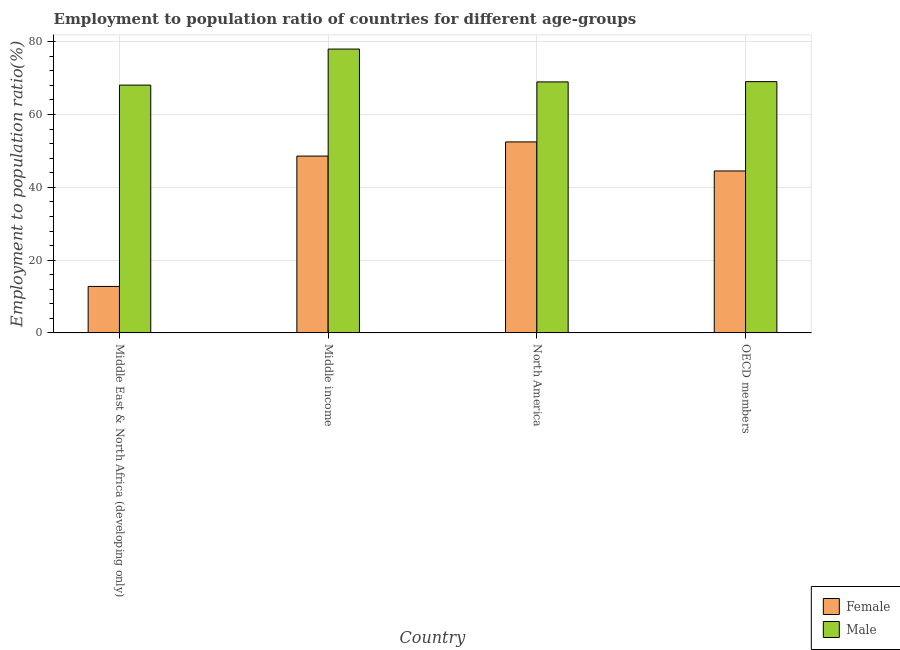How many groups of bars are there?
Make the answer very short. 4. How many bars are there on the 4th tick from the left?
Provide a succinct answer. 2. How many bars are there on the 4th tick from the right?
Make the answer very short. 2. What is the label of the 1st group of bars from the left?
Keep it short and to the point. Middle East & North Africa (developing only). What is the employment to population ratio(male) in Middle income?
Ensure brevity in your answer.  77.99. Across all countries, what is the maximum employment to population ratio(female)?
Offer a terse response. 52.48. Across all countries, what is the minimum employment to population ratio(female)?
Keep it short and to the point. 12.78. In which country was the employment to population ratio(male) maximum?
Offer a very short reply. Middle income. In which country was the employment to population ratio(female) minimum?
Your response must be concise. Middle East & North Africa (developing only). What is the total employment to population ratio(male) in the graph?
Your answer should be compact. 284.09. What is the difference between the employment to population ratio(male) in Middle East & North Africa (developing only) and that in North America?
Make the answer very short. -0.87. What is the difference between the employment to population ratio(male) in Middle income and the employment to population ratio(female) in Middle East & North Africa (developing only)?
Your response must be concise. 65.21. What is the average employment to population ratio(male) per country?
Your answer should be compact. 71.02. What is the difference between the employment to population ratio(male) and employment to population ratio(female) in Middle East & North Africa (developing only)?
Your answer should be very brief. 55.31. What is the ratio of the employment to population ratio(male) in Middle East & North Africa (developing only) to that in North America?
Your answer should be very brief. 0.99. Is the difference between the employment to population ratio(female) in Middle income and North America greater than the difference between the employment to population ratio(male) in Middle income and North America?
Offer a terse response. No. What is the difference between the highest and the second highest employment to population ratio(male)?
Keep it short and to the point. 8.95. What is the difference between the highest and the lowest employment to population ratio(male)?
Your answer should be very brief. 9.9. In how many countries, is the employment to population ratio(female) greater than the average employment to population ratio(female) taken over all countries?
Your response must be concise. 3. What does the 1st bar from the left in North America represents?
Your answer should be very brief. Female. Are all the bars in the graph horizontal?
Provide a succinct answer. No. What is the difference between two consecutive major ticks on the Y-axis?
Provide a succinct answer. 20. Are the values on the major ticks of Y-axis written in scientific E-notation?
Your answer should be compact. No. Where does the legend appear in the graph?
Your answer should be very brief. Bottom right. How many legend labels are there?
Ensure brevity in your answer.  2. What is the title of the graph?
Provide a succinct answer. Employment to population ratio of countries for different age-groups. What is the Employment to population ratio(%) in Female in Middle East & North Africa (developing only)?
Offer a very short reply. 12.78. What is the Employment to population ratio(%) of Male in Middle East & North Africa (developing only)?
Provide a succinct answer. 68.09. What is the Employment to population ratio(%) of Female in Middle income?
Ensure brevity in your answer.  48.59. What is the Employment to population ratio(%) of Male in Middle income?
Provide a succinct answer. 77.99. What is the Employment to population ratio(%) in Female in North America?
Offer a terse response. 52.48. What is the Employment to population ratio(%) in Male in North America?
Provide a short and direct response. 68.96. What is the Employment to population ratio(%) of Female in OECD members?
Make the answer very short. 44.5. What is the Employment to population ratio(%) of Male in OECD members?
Give a very brief answer. 69.04. Across all countries, what is the maximum Employment to population ratio(%) of Female?
Provide a short and direct response. 52.48. Across all countries, what is the maximum Employment to population ratio(%) in Male?
Provide a succinct answer. 77.99. Across all countries, what is the minimum Employment to population ratio(%) of Female?
Your answer should be very brief. 12.78. Across all countries, what is the minimum Employment to population ratio(%) in Male?
Your answer should be very brief. 68.09. What is the total Employment to population ratio(%) in Female in the graph?
Your response must be concise. 158.35. What is the total Employment to population ratio(%) of Male in the graph?
Your answer should be very brief. 284.09. What is the difference between the Employment to population ratio(%) in Female in Middle East & North Africa (developing only) and that in Middle income?
Provide a succinct answer. -35.81. What is the difference between the Employment to population ratio(%) of Female in Middle East & North Africa (developing only) and that in North America?
Offer a terse response. -39.7. What is the difference between the Employment to population ratio(%) in Male in Middle East & North Africa (developing only) and that in North America?
Make the answer very short. -0.87. What is the difference between the Employment to population ratio(%) in Female in Middle East & North Africa (developing only) and that in OECD members?
Offer a terse response. -31.72. What is the difference between the Employment to population ratio(%) of Male in Middle East & North Africa (developing only) and that in OECD members?
Your answer should be very brief. -0.95. What is the difference between the Employment to population ratio(%) in Female in Middle income and that in North America?
Offer a terse response. -3.89. What is the difference between the Employment to population ratio(%) of Male in Middle income and that in North America?
Offer a very short reply. 9.03. What is the difference between the Employment to population ratio(%) of Female in Middle income and that in OECD members?
Make the answer very short. 4.09. What is the difference between the Employment to population ratio(%) of Male in Middle income and that in OECD members?
Make the answer very short. 8.95. What is the difference between the Employment to population ratio(%) in Female in North America and that in OECD members?
Make the answer very short. 7.98. What is the difference between the Employment to population ratio(%) of Male in North America and that in OECD members?
Ensure brevity in your answer.  -0.08. What is the difference between the Employment to population ratio(%) in Female in Middle East & North Africa (developing only) and the Employment to population ratio(%) in Male in Middle income?
Your response must be concise. -65.21. What is the difference between the Employment to population ratio(%) in Female in Middle East & North Africa (developing only) and the Employment to population ratio(%) in Male in North America?
Ensure brevity in your answer.  -56.19. What is the difference between the Employment to population ratio(%) in Female in Middle East & North Africa (developing only) and the Employment to population ratio(%) in Male in OECD members?
Offer a terse response. -56.27. What is the difference between the Employment to population ratio(%) of Female in Middle income and the Employment to population ratio(%) of Male in North America?
Offer a very short reply. -20.37. What is the difference between the Employment to population ratio(%) in Female in Middle income and the Employment to population ratio(%) in Male in OECD members?
Make the answer very short. -20.45. What is the difference between the Employment to population ratio(%) of Female in North America and the Employment to population ratio(%) of Male in OECD members?
Offer a terse response. -16.56. What is the average Employment to population ratio(%) of Female per country?
Make the answer very short. 39.59. What is the average Employment to population ratio(%) in Male per country?
Provide a short and direct response. 71.02. What is the difference between the Employment to population ratio(%) in Female and Employment to population ratio(%) in Male in Middle East & North Africa (developing only)?
Keep it short and to the point. -55.31. What is the difference between the Employment to population ratio(%) of Female and Employment to population ratio(%) of Male in Middle income?
Ensure brevity in your answer.  -29.4. What is the difference between the Employment to population ratio(%) of Female and Employment to population ratio(%) of Male in North America?
Offer a terse response. -16.48. What is the difference between the Employment to population ratio(%) of Female and Employment to population ratio(%) of Male in OECD members?
Make the answer very short. -24.55. What is the ratio of the Employment to population ratio(%) of Female in Middle East & North Africa (developing only) to that in Middle income?
Provide a succinct answer. 0.26. What is the ratio of the Employment to population ratio(%) in Male in Middle East & North Africa (developing only) to that in Middle income?
Ensure brevity in your answer.  0.87. What is the ratio of the Employment to population ratio(%) in Female in Middle East & North Africa (developing only) to that in North America?
Your answer should be very brief. 0.24. What is the ratio of the Employment to population ratio(%) of Male in Middle East & North Africa (developing only) to that in North America?
Your answer should be very brief. 0.99. What is the ratio of the Employment to population ratio(%) of Female in Middle East & North Africa (developing only) to that in OECD members?
Provide a succinct answer. 0.29. What is the ratio of the Employment to population ratio(%) in Male in Middle East & North Africa (developing only) to that in OECD members?
Make the answer very short. 0.99. What is the ratio of the Employment to population ratio(%) of Female in Middle income to that in North America?
Your answer should be very brief. 0.93. What is the ratio of the Employment to population ratio(%) of Male in Middle income to that in North America?
Offer a terse response. 1.13. What is the ratio of the Employment to population ratio(%) in Female in Middle income to that in OECD members?
Offer a terse response. 1.09. What is the ratio of the Employment to population ratio(%) in Male in Middle income to that in OECD members?
Make the answer very short. 1.13. What is the ratio of the Employment to population ratio(%) of Female in North America to that in OECD members?
Offer a very short reply. 1.18. What is the difference between the highest and the second highest Employment to population ratio(%) of Female?
Your answer should be compact. 3.89. What is the difference between the highest and the second highest Employment to population ratio(%) of Male?
Offer a very short reply. 8.95. What is the difference between the highest and the lowest Employment to population ratio(%) in Female?
Your response must be concise. 39.7. What is the difference between the highest and the lowest Employment to population ratio(%) of Male?
Ensure brevity in your answer.  9.9. 